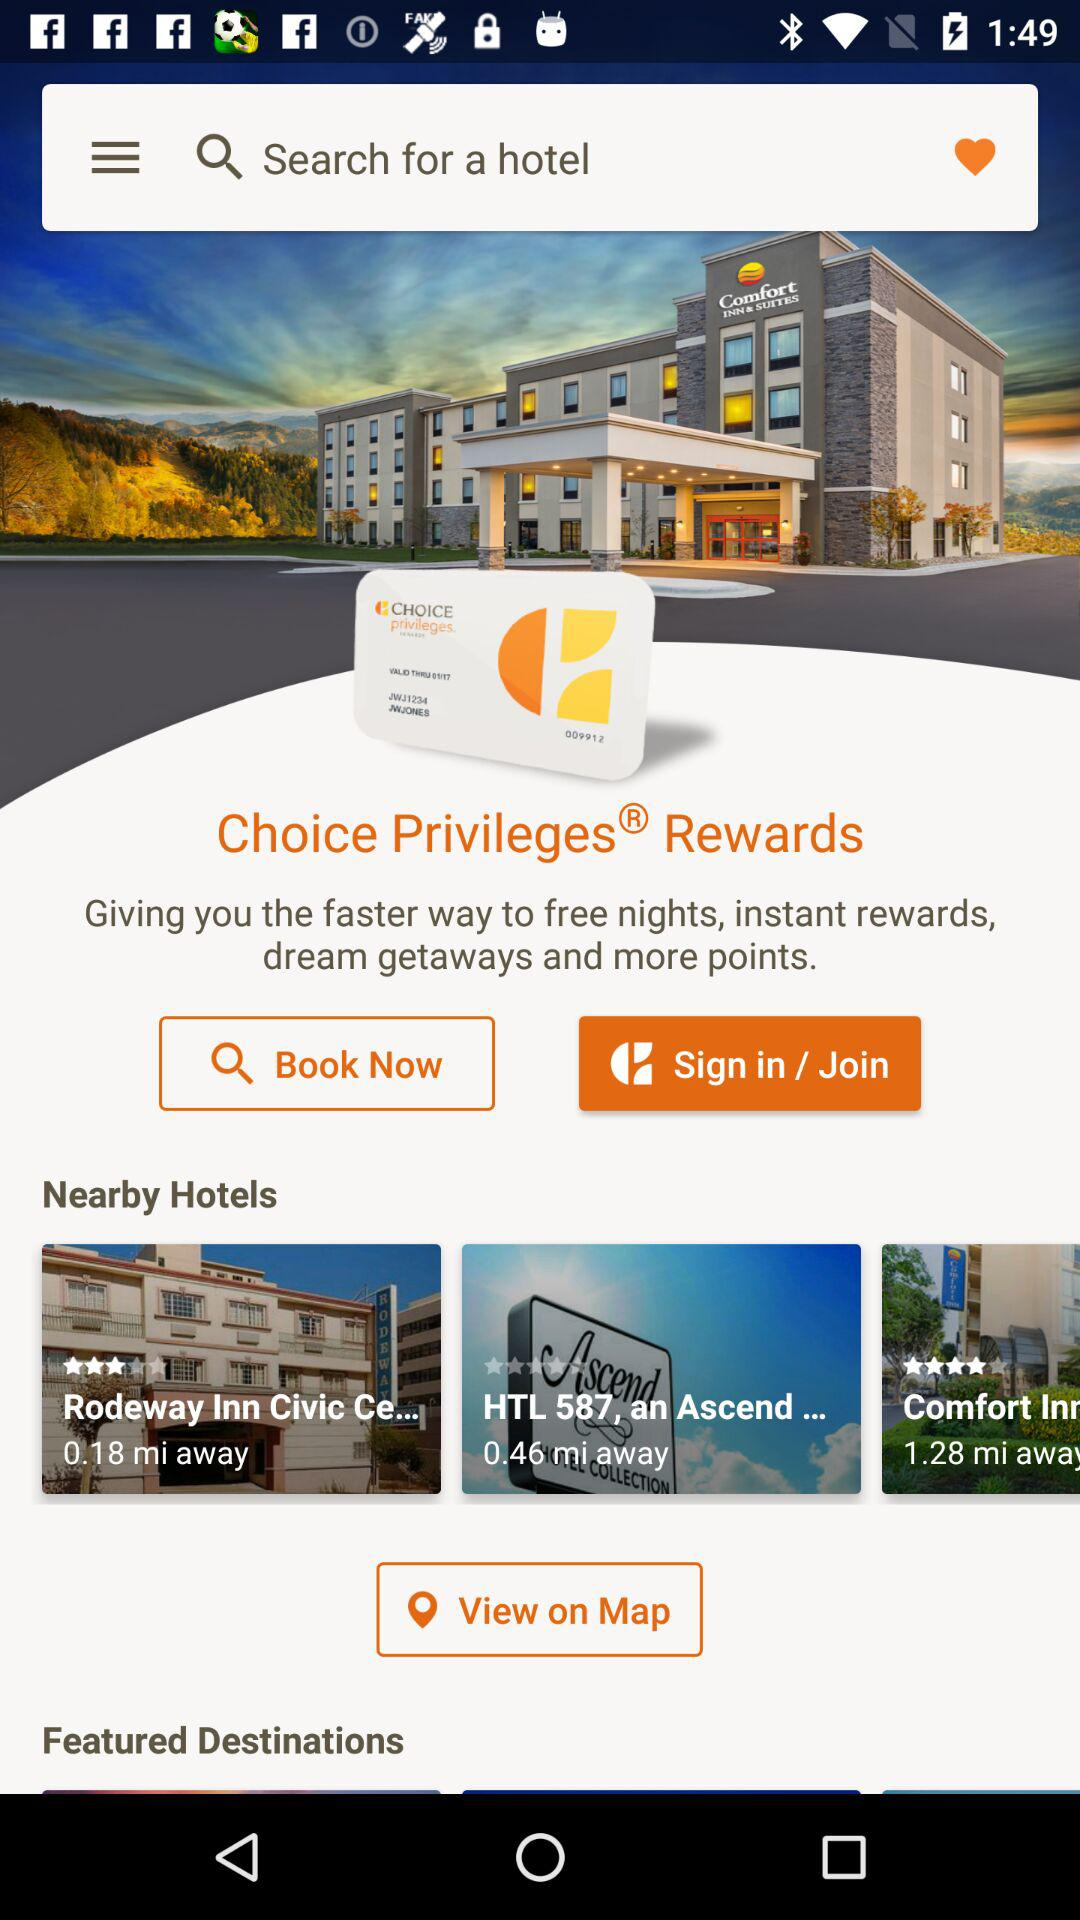Which featured destinations can be viewed on the map?
When the provided information is insufficient, respond with <no answer>. <no answer> 